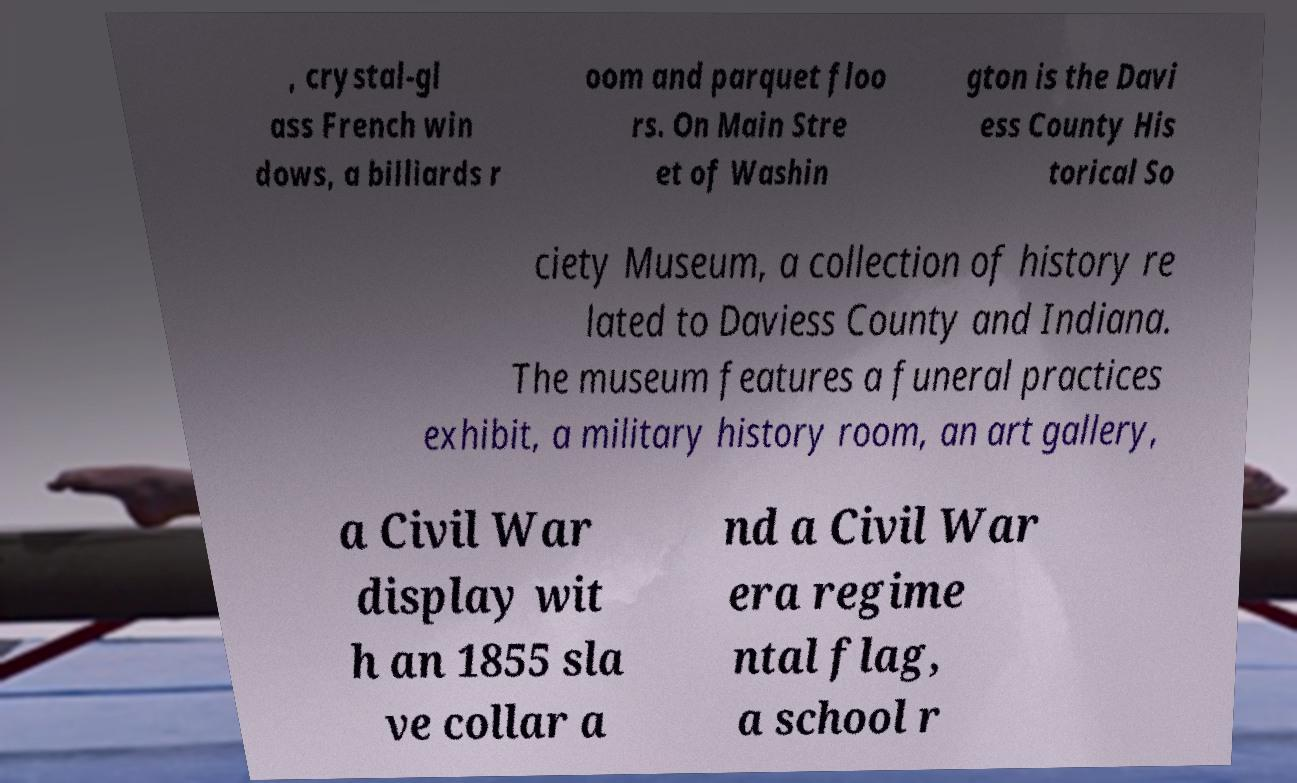What messages or text are displayed in this image? I need them in a readable, typed format. , crystal-gl ass French win dows, a billiards r oom and parquet floo rs. On Main Stre et of Washin gton is the Davi ess County His torical So ciety Museum, a collection of history re lated to Daviess County and Indiana. The museum features a funeral practices exhibit, a military history room, an art gallery, a Civil War display wit h an 1855 sla ve collar a nd a Civil War era regime ntal flag, a school r 